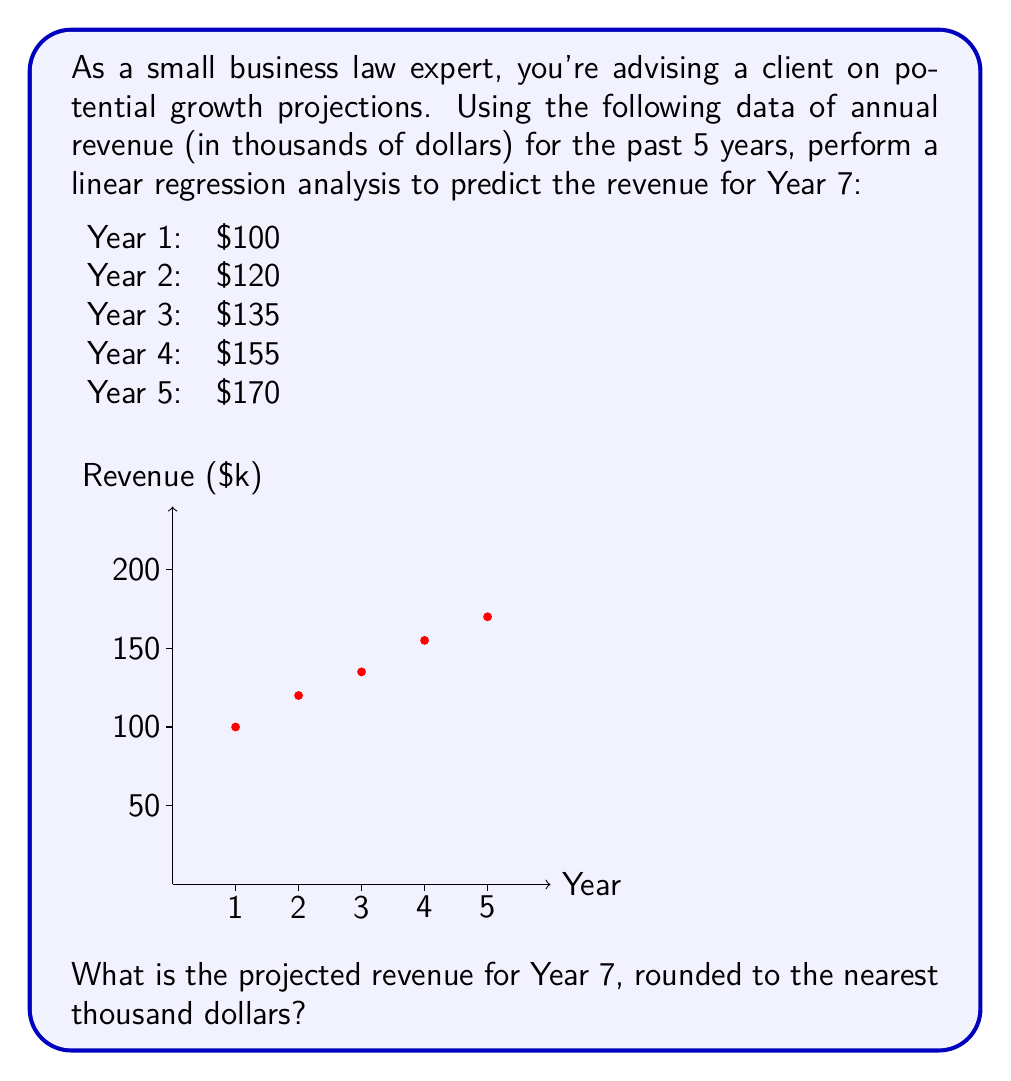Provide a solution to this math problem. To predict the revenue for Year 7 using linear regression, we'll follow these steps:

1) First, we need to calculate the slope (m) and y-intercept (b) of the regression line y = mx + b.

2) The formulas for m and b are:

   $$m = \frac{n\sum xy - \sum x \sum y}{n\sum x^2 - (\sum x)^2}$$
   
   $$b = \frac{\sum y - m\sum x}{n}$$

   where n is the number of data points.

3) Let's calculate the necessary sums:
   
   $n = 5$
   $\sum x = 1 + 2 + 3 + 4 + 5 = 15$
   $\sum y = 100 + 120 + 135 + 155 + 170 = 680$
   $\sum xy = 1(100) + 2(120) + 3(135) + 4(155) + 5(170) = 2290$
   $\sum x^2 = 1^2 + 2^2 + 3^2 + 4^2 + 5^2 = 55$

4) Now we can calculate m:

   $$m = \frac{5(2290) - 15(680)}{5(55) - 15^2} = \frac{11450 - 10200}{275 - 225} = \frac{1250}{50} = 25$$

5) And b:

   $$b = \frac{680 - 25(15)}{5} = \frac{680 - 375}{5} = 61$$

6) So our regression line is: y = 25x + 61

7) To predict Year 7, we plug in x = 7:

   y = 25(7) + 61 = 175 + 61 = 236

8) Rounding to the nearest thousand: 236,000
Answer: $236,000 